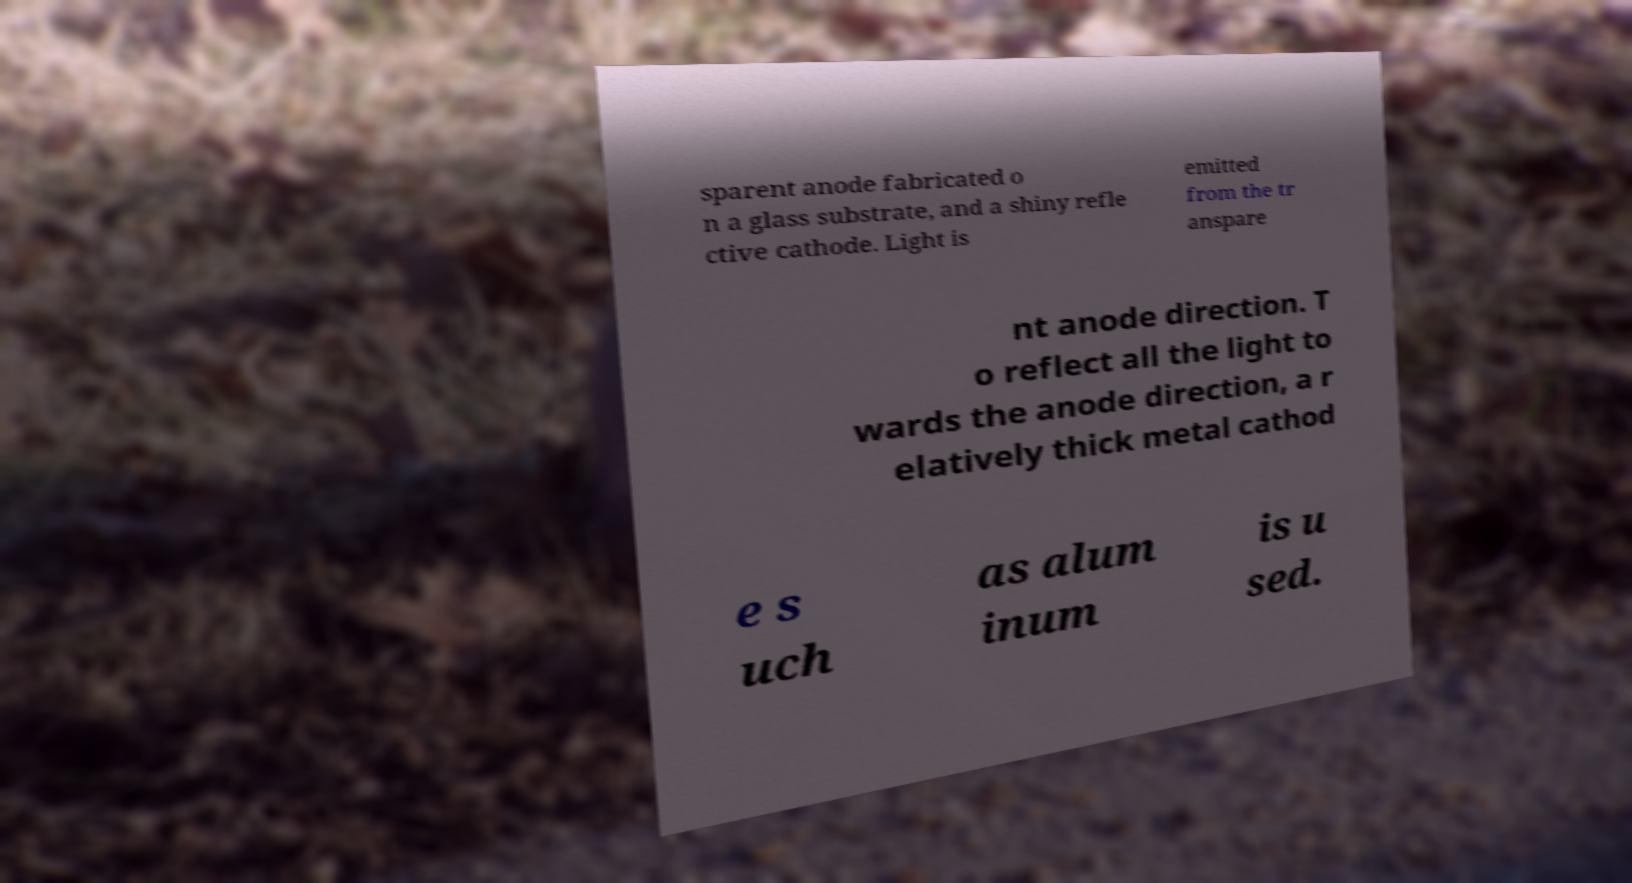Could you assist in decoding the text presented in this image and type it out clearly? sparent anode fabricated o n a glass substrate, and a shiny refle ctive cathode. Light is emitted from the tr anspare nt anode direction. T o reflect all the light to wards the anode direction, a r elatively thick metal cathod e s uch as alum inum is u sed. 